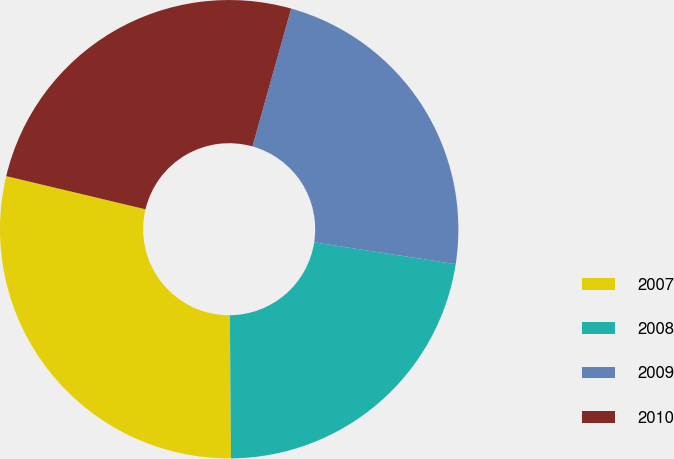<chart> <loc_0><loc_0><loc_500><loc_500><pie_chart><fcel>2007<fcel>2008<fcel>2009<fcel>2010<nl><fcel>28.85%<fcel>22.44%<fcel>23.08%<fcel>25.64%<nl></chart> 